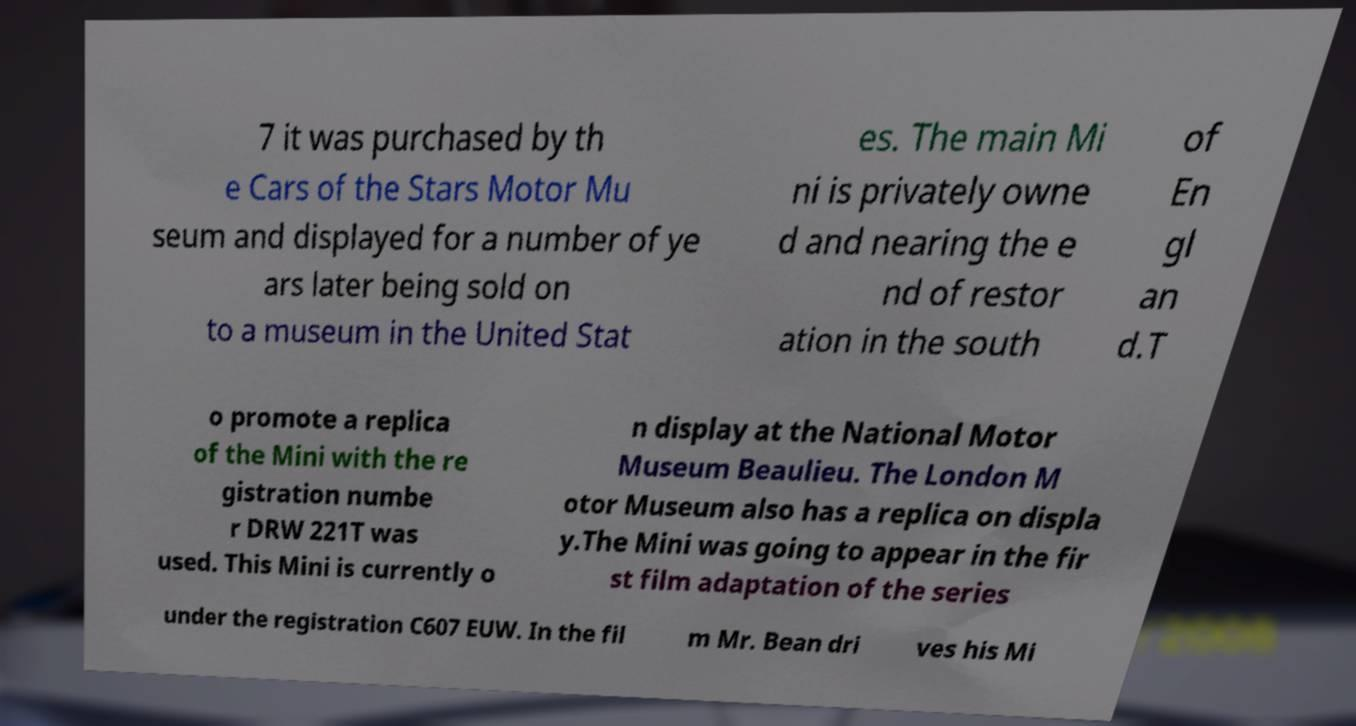Please read and relay the text visible in this image. What does it say? 7 it was purchased by th e Cars of the Stars Motor Mu seum and displayed for a number of ye ars later being sold on to a museum in the United Stat es. The main Mi ni is privately owne d and nearing the e nd of restor ation in the south of En gl an d.T o promote a replica of the Mini with the re gistration numbe r DRW 221T was used. This Mini is currently o n display at the National Motor Museum Beaulieu. The London M otor Museum also has a replica on displa y.The Mini was going to appear in the fir st film adaptation of the series under the registration C607 EUW. In the fil m Mr. Bean dri ves his Mi 